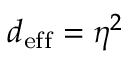Convert formula to latex. <formula><loc_0><loc_0><loc_500><loc_500>d _ { e f f } = \eta ^ { 2 }</formula> 